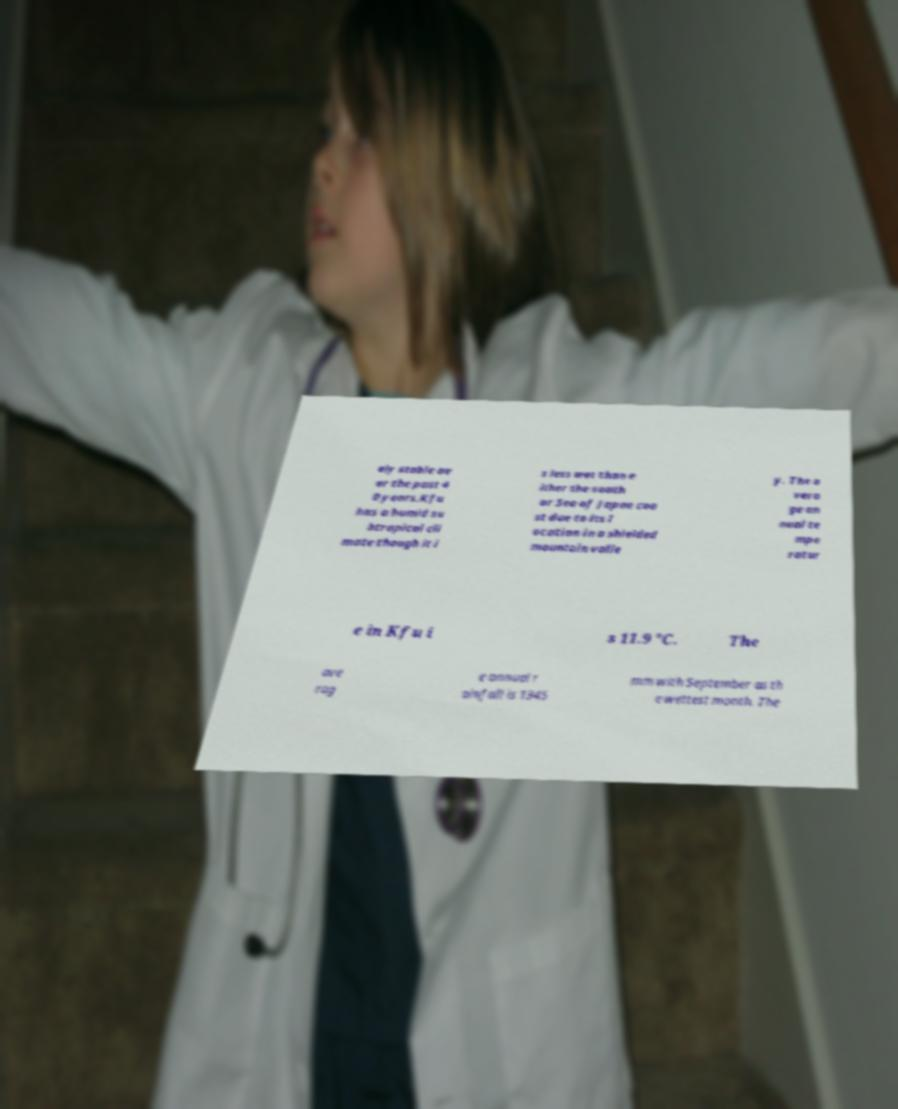What messages or text are displayed in this image? I need them in a readable, typed format. ely stable ov er the past 4 0 years.Kfu has a humid su btropical cli mate though it i s less wet than e ither the south or Sea of Japan coa st due to its l ocation in a shielded mountain valle y. The a vera ge an nual te mpe ratur e in Kfu i s 11.9 °C. The ave rag e annual r ainfall is 1345 mm with September as th e wettest month. The 